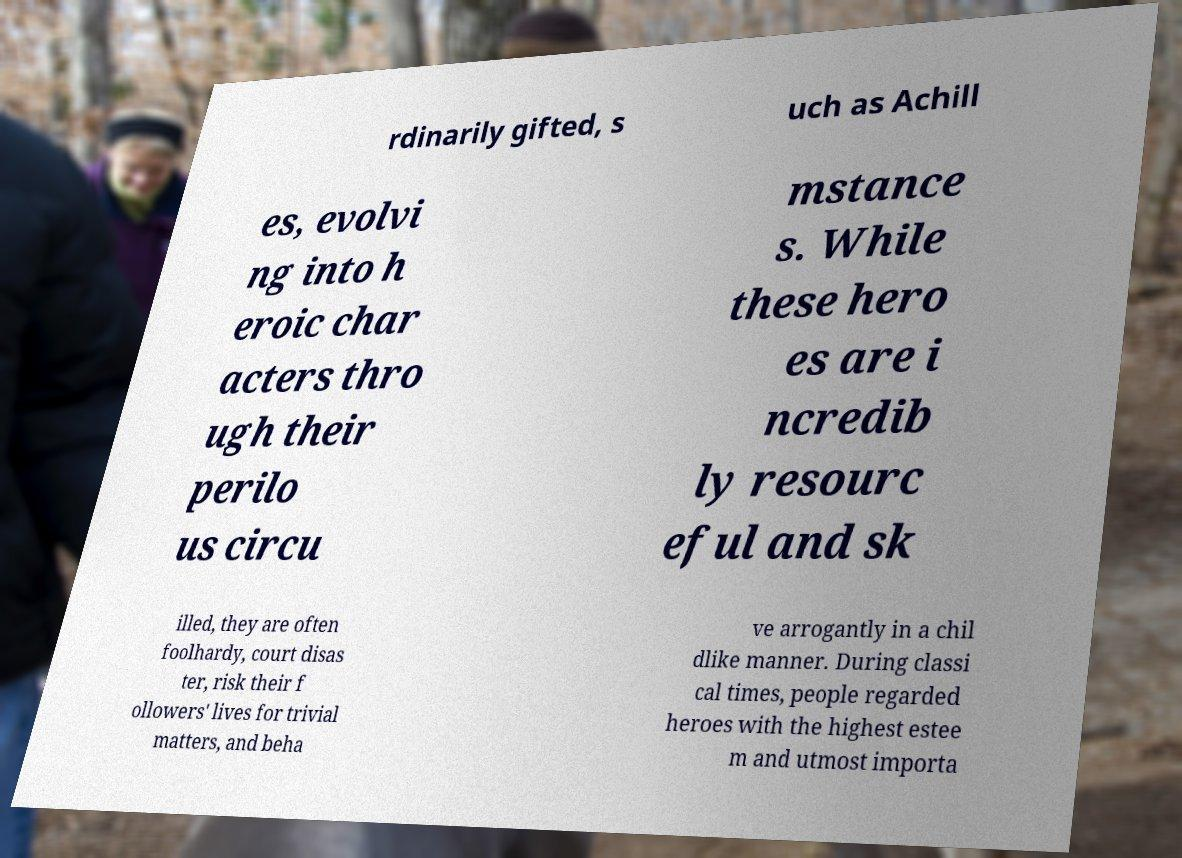Can you accurately transcribe the text from the provided image for me? rdinarily gifted, s uch as Achill es, evolvi ng into h eroic char acters thro ugh their perilo us circu mstance s. While these hero es are i ncredib ly resourc eful and sk illed, they are often foolhardy, court disas ter, risk their f ollowers' lives for trivial matters, and beha ve arrogantly in a chil dlike manner. During classi cal times, people regarded heroes with the highest estee m and utmost importa 